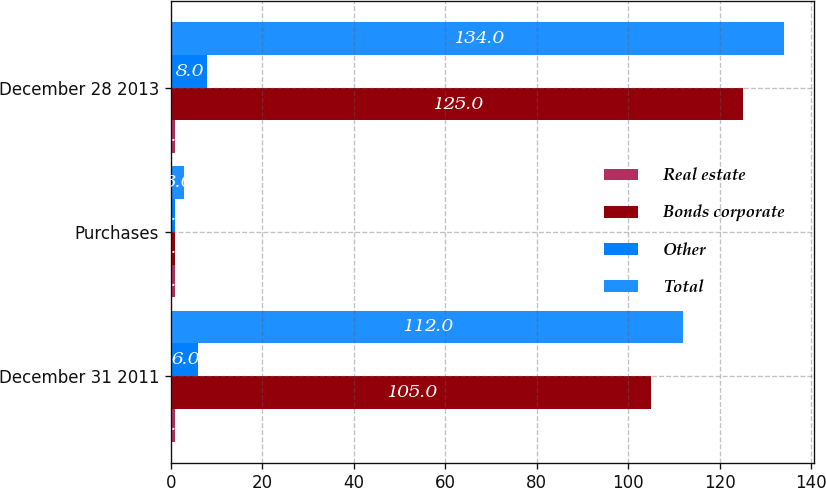<chart> <loc_0><loc_0><loc_500><loc_500><stacked_bar_chart><ecel><fcel>December 31 2011<fcel>Purchases<fcel>December 28 2013<nl><fcel>Real estate<fcel>1<fcel>1<fcel>1<nl><fcel>Bonds corporate<fcel>105<fcel>1<fcel>125<nl><fcel>Other<fcel>6<fcel>1<fcel>8<nl><fcel>Total<fcel>112<fcel>3<fcel>134<nl></chart> 